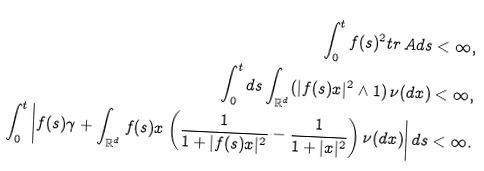Convert formula to latex. <formula><loc_0><loc_0><loc_500><loc_500>\int _ { 0 } ^ { t } f ( s ) ^ { 2 } t r \, A d s < \infty , \\ \int _ { 0 } ^ { t } d s \int _ { \mathbb { R } ^ { d } } ( | f ( s ) x | ^ { 2 } \land 1 ) \, \nu ( d x ) < \infty , \\ \int _ { 0 } ^ { t } \left | f ( s ) \gamma + \int _ { \mathbb { R } ^ { d } } f ( s ) x \left ( \frac { 1 } { 1 + | f ( s ) x | ^ { 2 } } - \frac { 1 } { 1 + | x | ^ { 2 } } \right ) \nu ( d x ) \right | d s < \infty .</formula> 